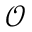Convert formula to latex. <formula><loc_0><loc_0><loc_500><loc_500>\mathcal { O }</formula> 